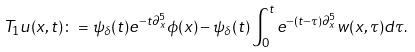<formula> <loc_0><loc_0><loc_500><loc_500>T _ { 1 } u ( x , t ) \colon = \psi _ { \delta } ( t ) e ^ { - t \partial _ { x } ^ { 5 } } \phi ( x ) - \psi _ { \delta } ( t ) \int _ { 0 } ^ { t } e ^ { - ( t - \tau ) \partial _ { x } ^ { 5 } } w ( x , \tau ) d \tau .</formula> 